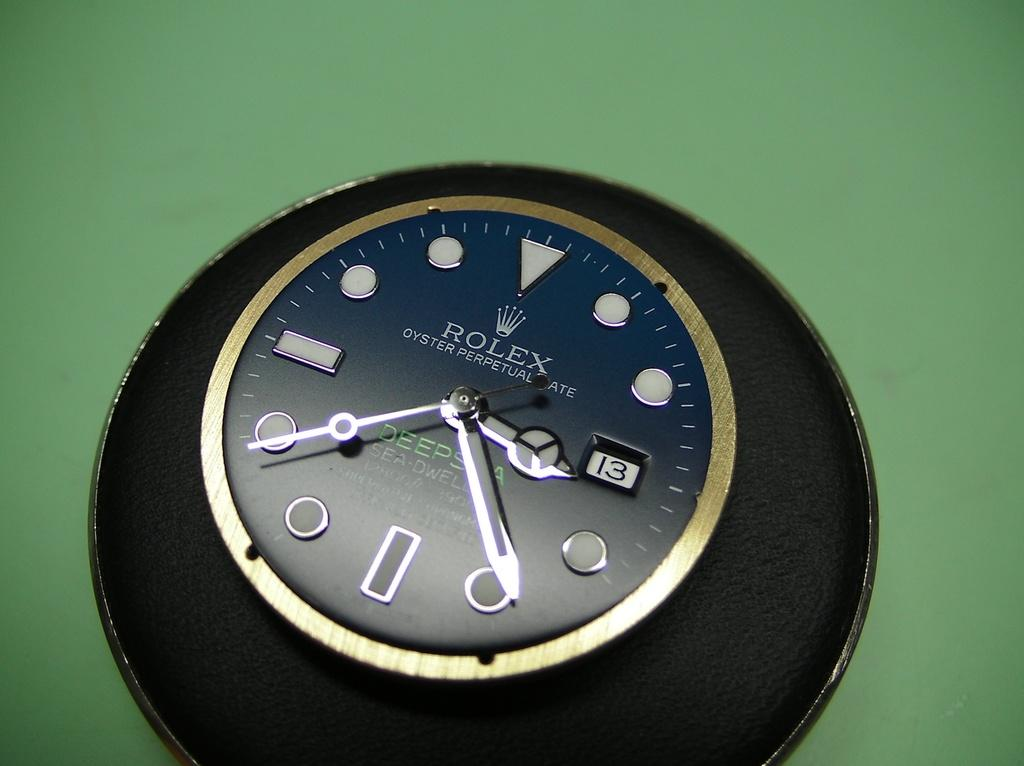<image>
Render a clear and concise summary of the photo. A black Rolex Oyster Perpetual Rate Deepsea Superlative Chronomatic clock. 